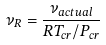Convert formula to latex. <formula><loc_0><loc_0><loc_500><loc_500>\nu _ { R } = { \frac { \nu _ { a c t u a l } } { R T _ { c r } / P _ { c r } } }</formula> 